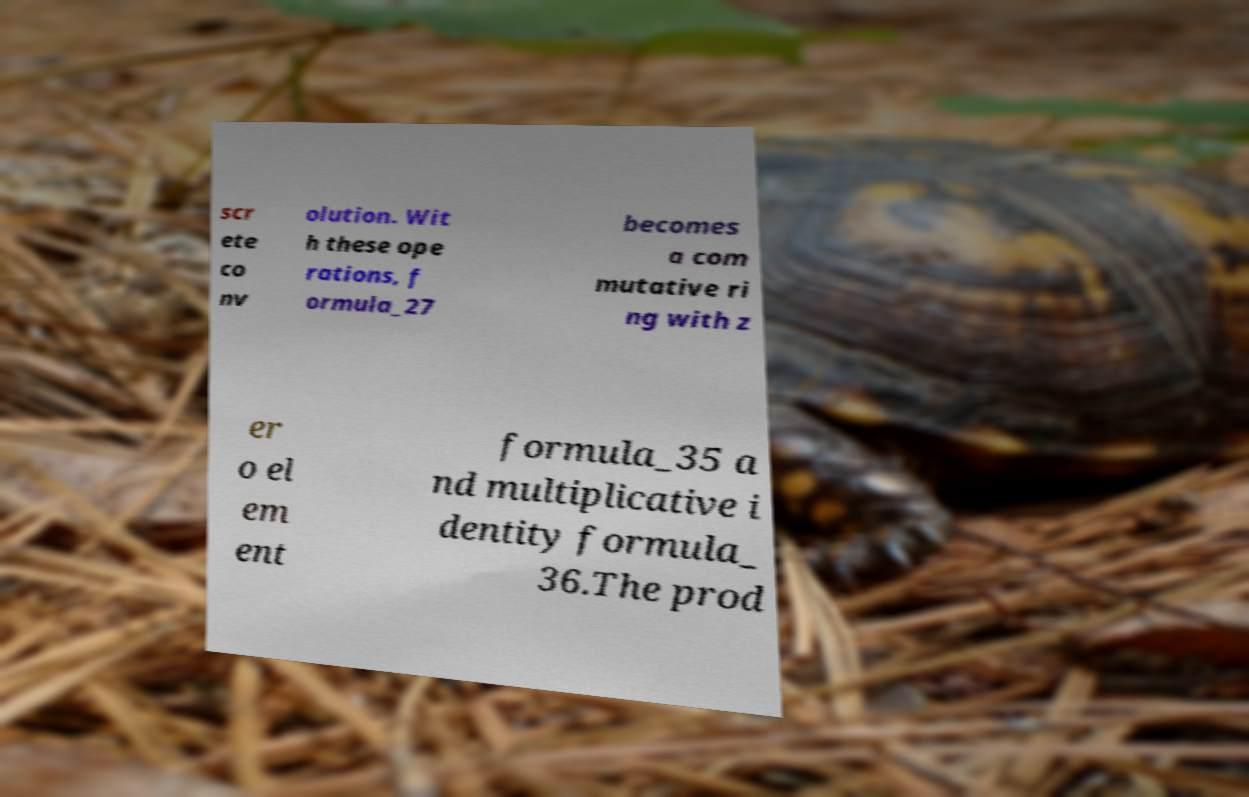Could you extract and type out the text from this image? scr ete co nv olution. Wit h these ope rations, f ormula_27 becomes a com mutative ri ng with z er o el em ent formula_35 a nd multiplicative i dentity formula_ 36.The prod 